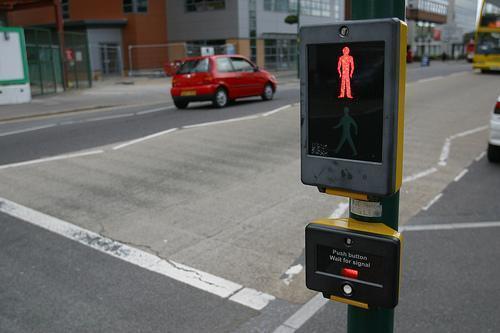How many white cars are there?
Give a very brief answer. 0. 